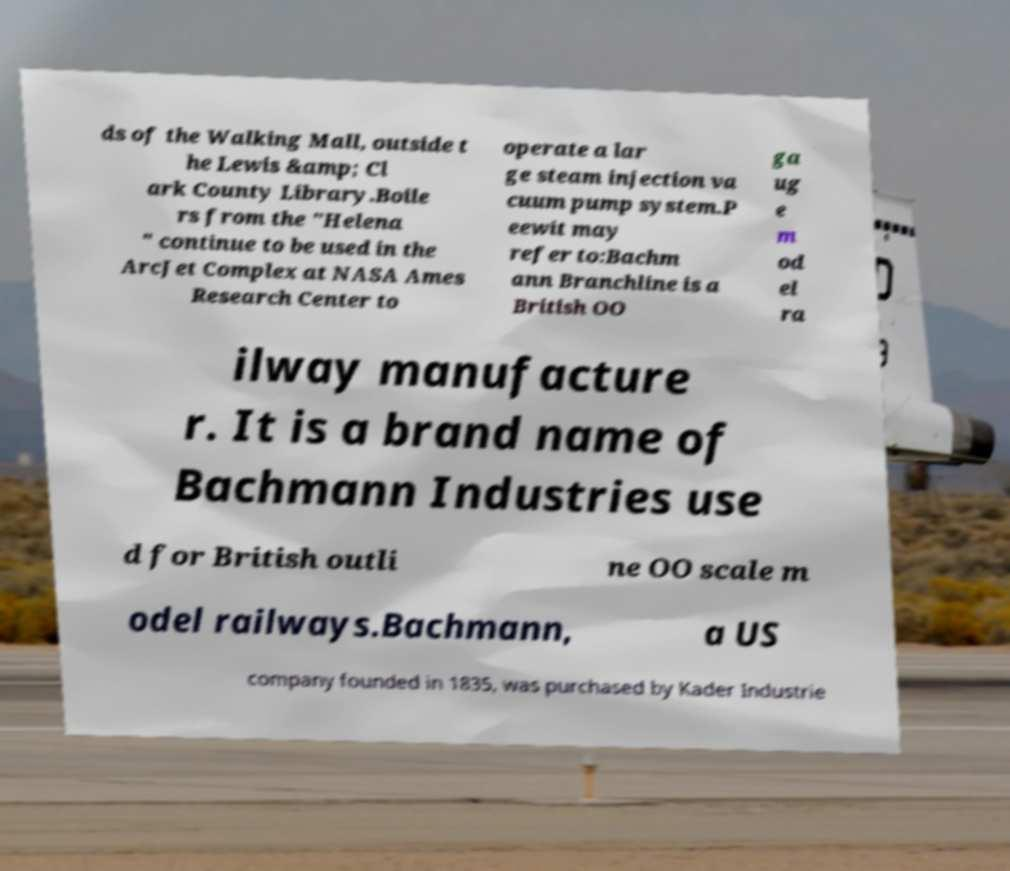Can you read and provide the text displayed in the image?This photo seems to have some interesting text. Can you extract and type it out for me? ds of the Walking Mall, outside t he Lewis &amp; Cl ark County Library.Boile rs from the "Helena " continue to be used in the ArcJet Complex at NASA Ames Research Center to operate a lar ge steam injection va cuum pump system.P eewit may refer to:Bachm ann Branchline is a British OO ga ug e m od el ra ilway manufacture r. It is a brand name of Bachmann Industries use d for British outli ne OO scale m odel railways.Bachmann, a US company founded in 1835, was purchased by Kader Industrie 